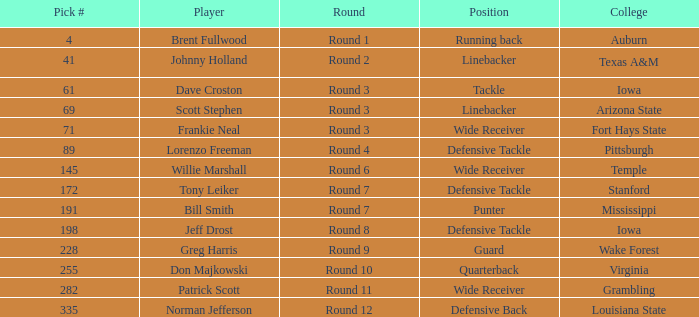What is the largest pick# for Greg Harris? 228.0. 